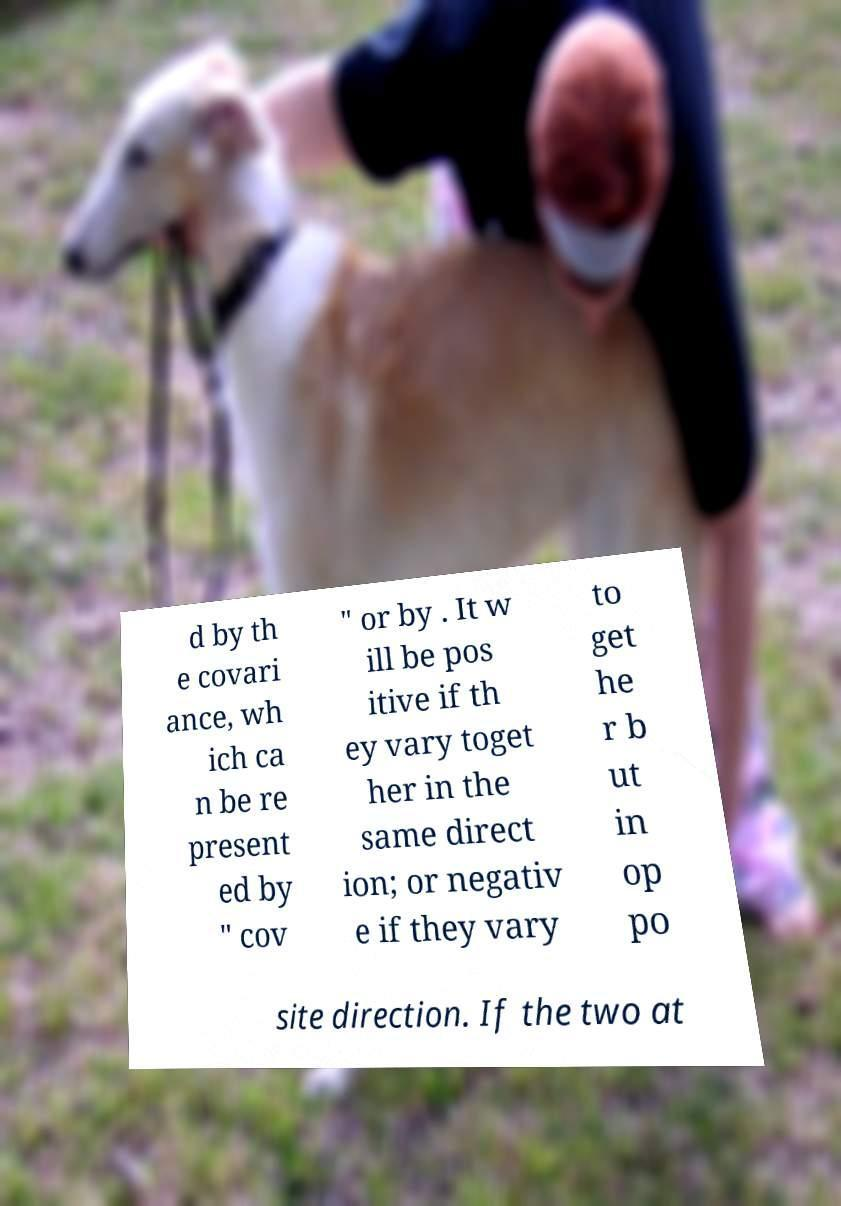Can you accurately transcribe the text from the provided image for me? d by th e covari ance, wh ich ca n be re present ed by " cov " or by . It w ill be pos itive if th ey vary toget her in the same direct ion; or negativ e if they vary to get he r b ut in op po site direction. If the two at 